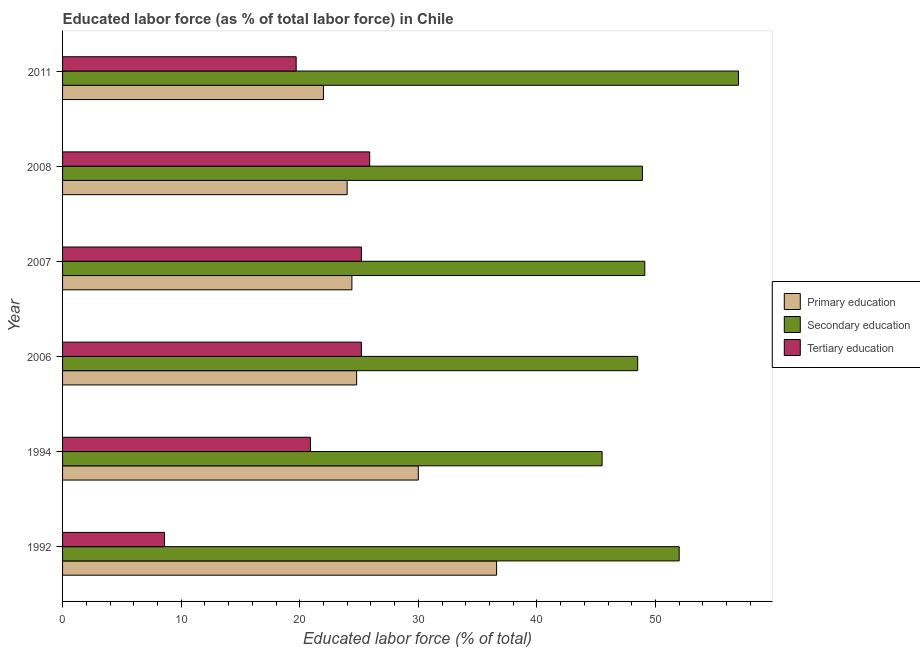Are the number of bars on each tick of the Y-axis equal?
Your answer should be compact. Yes. What is the label of the 2nd group of bars from the top?
Keep it short and to the point. 2008. What is the percentage of labor force who received primary education in 2007?
Your answer should be compact. 24.4. Across all years, what is the maximum percentage of labor force who received primary education?
Give a very brief answer. 36.6. Across all years, what is the minimum percentage of labor force who received tertiary education?
Ensure brevity in your answer.  8.6. What is the total percentage of labor force who received tertiary education in the graph?
Your response must be concise. 125.5. What is the difference between the percentage of labor force who received primary education in 2006 and the percentage of labor force who received tertiary education in 1994?
Offer a terse response. 3.9. What is the average percentage of labor force who received primary education per year?
Your response must be concise. 26.97. In the year 2006, what is the difference between the percentage of labor force who received secondary education and percentage of labor force who received primary education?
Give a very brief answer. 23.7. What is the ratio of the percentage of labor force who received secondary education in 2008 to that in 2011?
Provide a succinct answer. 0.86. Is the difference between the percentage of labor force who received secondary education in 2006 and 2008 greater than the difference between the percentage of labor force who received primary education in 2006 and 2008?
Provide a short and direct response. No. What is the difference between the highest and the lowest percentage of labor force who received secondary education?
Give a very brief answer. 11.5. In how many years, is the percentage of labor force who received secondary education greater than the average percentage of labor force who received secondary education taken over all years?
Provide a short and direct response. 2. Is the sum of the percentage of labor force who received primary education in 1994 and 2008 greater than the maximum percentage of labor force who received secondary education across all years?
Ensure brevity in your answer.  No. What does the 2nd bar from the bottom in 1994 represents?
Offer a terse response. Secondary education. How many bars are there?
Your answer should be very brief. 18. Are all the bars in the graph horizontal?
Your answer should be compact. Yes. How many years are there in the graph?
Offer a terse response. 6. What is the difference between two consecutive major ticks on the X-axis?
Provide a short and direct response. 10. Are the values on the major ticks of X-axis written in scientific E-notation?
Provide a succinct answer. No. How many legend labels are there?
Ensure brevity in your answer.  3. How are the legend labels stacked?
Keep it short and to the point. Vertical. What is the title of the graph?
Give a very brief answer. Educated labor force (as % of total labor force) in Chile. Does "Profit Tax" appear as one of the legend labels in the graph?
Make the answer very short. No. What is the label or title of the X-axis?
Your answer should be compact. Educated labor force (% of total). What is the Educated labor force (% of total) of Primary education in 1992?
Keep it short and to the point. 36.6. What is the Educated labor force (% of total) of Tertiary education in 1992?
Your answer should be compact. 8.6. What is the Educated labor force (% of total) of Primary education in 1994?
Ensure brevity in your answer.  30. What is the Educated labor force (% of total) of Secondary education in 1994?
Give a very brief answer. 45.5. What is the Educated labor force (% of total) in Tertiary education in 1994?
Ensure brevity in your answer.  20.9. What is the Educated labor force (% of total) of Primary education in 2006?
Provide a short and direct response. 24.8. What is the Educated labor force (% of total) in Secondary education in 2006?
Give a very brief answer. 48.5. What is the Educated labor force (% of total) in Tertiary education in 2006?
Give a very brief answer. 25.2. What is the Educated labor force (% of total) of Primary education in 2007?
Provide a short and direct response. 24.4. What is the Educated labor force (% of total) of Secondary education in 2007?
Keep it short and to the point. 49.1. What is the Educated labor force (% of total) in Tertiary education in 2007?
Give a very brief answer. 25.2. What is the Educated labor force (% of total) in Primary education in 2008?
Your answer should be compact. 24. What is the Educated labor force (% of total) in Secondary education in 2008?
Provide a succinct answer. 48.9. What is the Educated labor force (% of total) in Tertiary education in 2008?
Keep it short and to the point. 25.9. What is the Educated labor force (% of total) in Primary education in 2011?
Your answer should be compact. 22. What is the Educated labor force (% of total) of Tertiary education in 2011?
Your response must be concise. 19.7. Across all years, what is the maximum Educated labor force (% of total) of Primary education?
Your answer should be very brief. 36.6. Across all years, what is the maximum Educated labor force (% of total) in Secondary education?
Your answer should be very brief. 57. Across all years, what is the maximum Educated labor force (% of total) of Tertiary education?
Provide a succinct answer. 25.9. Across all years, what is the minimum Educated labor force (% of total) in Primary education?
Give a very brief answer. 22. Across all years, what is the minimum Educated labor force (% of total) of Secondary education?
Keep it short and to the point. 45.5. Across all years, what is the minimum Educated labor force (% of total) in Tertiary education?
Keep it short and to the point. 8.6. What is the total Educated labor force (% of total) of Primary education in the graph?
Your answer should be very brief. 161.8. What is the total Educated labor force (% of total) in Secondary education in the graph?
Provide a short and direct response. 301. What is the total Educated labor force (% of total) of Tertiary education in the graph?
Your answer should be compact. 125.5. What is the difference between the Educated labor force (% of total) of Primary education in 1992 and that in 1994?
Provide a short and direct response. 6.6. What is the difference between the Educated labor force (% of total) of Secondary education in 1992 and that in 1994?
Make the answer very short. 6.5. What is the difference between the Educated labor force (% of total) in Tertiary education in 1992 and that in 1994?
Your answer should be very brief. -12.3. What is the difference between the Educated labor force (% of total) of Secondary education in 1992 and that in 2006?
Provide a short and direct response. 3.5. What is the difference between the Educated labor force (% of total) in Tertiary education in 1992 and that in 2006?
Provide a succinct answer. -16.6. What is the difference between the Educated labor force (% of total) of Tertiary education in 1992 and that in 2007?
Provide a succinct answer. -16.6. What is the difference between the Educated labor force (% of total) of Tertiary education in 1992 and that in 2008?
Offer a terse response. -17.3. What is the difference between the Educated labor force (% of total) in Secondary education in 1992 and that in 2011?
Your answer should be very brief. -5. What is the difference between the Educated labor force (% of total) of Primary education in 1994 and that in 2007?
Your answer should be very brief. 5.6. What is the difference between the Educated labor force (% of total) of Secondary education in 1994 and that in 2007?
Offer a terse response. -3.6. What is the difference between the Educated labor force (% of total) of Tertiary education in 1994 and that in 2007?
Provide a short and direct response. -4.3. What is the difference between the Educated labor force (% of total) of Primary education in 1994 and that in 2008?
Keep it short and to the point. 6. What is the difference between the Educated labor force (% of total) in Secondary education in 1994 and that in 2008?
Your answer should be very brief. -3.4. What is the difference between the Educated labor force (% of total) of Tertiary education in 1994 and that in 2008?
Keep it short and to the point. -5. What is the difference between the Educated labor force (% of total) in Primary education in 1994 and that in 2011?
Provide a short and direct response. 8. What is the difference between the Educated labor force (% of total) in Secondary education in 1994 and that in 2011?
Ensure brevity in your answer.  -11.5. What is the difference between the Educated labor force (% of total) of Primary education in 2006 and that in 2007?
Provide a succinct answer. 0.4. What is the difference between the Educated labor force (% of total) in Secondary education in 2006 and that in 2007?
Keep it short and to the point. -0.6. What is the difference between the Educated labor force (% of total) in Tertiary education in 2006 and that in 2007?
Make the answer very short. 0. What is the difference between the Educated labor force (% of total) in Primary education in 2006 and that in 2008?
Ensure brevity in your answer.  0.8. What is the difference between the Educated labor force (% of total) of Secondary education in 2006 and that in 2008?
Keep it short and to the point. -0.4. What is the difference between the Educated labor force (% of total) in Secondary education in 2006 and that in 2011?
Give a very brief answer. -8.5. What is the difference between the Educated labor force (% of total) in Primary education in 2007 and that in 2008?
Ensure brevity in your answer.  0.4. What is the difference between the Educated labor force (% of total) in Secondary education in 2007 and that in 2008?
Offer a terse response. 0.2. What is the difference between the Educated labor force (% of total) of Tertiary education in 2007 and that in 2008?
Offer a terse response. -0.7. What is the difference between the Educated labor force (% of total) in Secondary education in 2007 and that in 2011?
Keep it short and to the point. -7.9. What is the difference between the Educated labor force (% of total) of Primary education in 2008 and that in 2011?
Your response must be concise. 2. What is the difference between the Educated labor force (% of total) of Secondary education in 2008 and that in 2011?
Ensure brevity in your answer.  -8.1. What is the difference between the Educated labor force (% of total) of Primary education in 1992 and the Educated labor force (% of total) of Secondary education in 1994?
Give a very brief answer. -8.9. What is the difference between the Educated labor force (% of total) of Primary education in 1992 and the Educated labor force (% of total) of Tertiary education in 1994?
Provide a succinct answer. 15.7. What is the difference between the Educated labor force (% of total) in Secondary education in 1992 and the Educated labor force (% of total) in Tertiary education in 1994?
Your answer should be compact. 31.1. What is the difference between the Educated labor force (% of total) in Primary education in 1992 and the Educated labor force (% of total) in Secondary education in 2006?
Your response must be concise. -11.9. What is the difference between the Educated labor force (% of total) of Primary education in 1992 and the Educated labor force (% of total) of Tertiary education in 2006?
Ensure brevity in your answer.  11.4. What is the difference between the Educated labor force (% of total) of Secondary education in 1992 and the Educated labor force (% of total) of Tertiary education in 2006?
Your answer should be compact. 26.8. What is the difference between the Educated labor force (% of total) in Secondary education in 1992 and the Educated labor force (% of total) in Tertiary education in 2007?
Keep it short and to the point. 26.8. What is the difference between the Educated labor force (% of total) in Primary education in 1992 and the Educated labor force (% of total) in Secondary education in 2008?
Make the answer very short. -12.3. What is the difference between the Educated labor force (% of total) in Secondary education in 1992 and the Educated labor force (% of total) in Tertiary education in 2008?
Keep it short and to the point. 26.1. What is the difference between the Educated labor force (% of total) of Primary education in 1992 and the Educated labor force (% of total) of Secondary education in 2011?
Make the answer very short. -20.4. What is the difference between the Educated labor force (% of total) of Primary education in 1992 and the Educated labor force (% of total) of Tertiary education in 2011?
Your answer should be compact. 16.9. What is the difference between the Educated labor force (% of total) in Secondary education in 1992 and the Educated labor force (% of total) in Tertiary education in 2011?
Ensure brevity in your answer.  32.3. What is the difference between the Educated labor force (% of total) of Primary education in 1994 and the Educated labor force (% of total) of Secondary education in 2006?
Offer a terse response. -18.5. What is the difference between the Educated labor force (% of total) of Primary education in 1994 and the Educated labor force (% of total) of Tertiary education in 2006?
Your answer should be compact. 4.8. What is the difference between the Educated labor force (% of total) in Secondary education in 1994 and the Educated labor force (% of total) in Tertiary education in 2006?
Give a very brief answer. 20.3. What is the difference between the Educated labor force (% of total) in Primary education in 1994 and the Educated labor force (% of total) in Secondary education in 2007?
Your response must be concise. -19.1. What is the difference between the Educated labor force (% of total) of Primary education in 1994 and the Educated labor force (% of total) of Tertiary education in 2007?
Your answer should be compact. 4.8. What is the difference between the Educated labor force (% of total) in Secondary education in 1994 and the Educated labor force (% of total) in Tertiary education in 2007?
Ensure brevity in your answer.  20.3. What is the difference between the Educated labor force (% of total) of Primary education in 1994 and the Educated labor force (% of total) of Secondary education in 2008?
Ensure brevity in your answer.  -18.9. What is the difference between the Educated labor force (% of total) in Secondary education in 1994 and the Educated labor force (% of total) in Tertiary education in 2008?
Offer a very short reply. 19.6. What is the difference between the Educated labor force (% of total) of Secondary education in 1994 and the Educated labor force (% of total) of Tertiary education in 2011?
Give a very brief answer. 25.8. What is the difference between the Educated labor force (% of total) in Primary education in 2006 and the Educated labor force (% of total) in Secondary education in 2007?
Provide a short and direct response. -24.3. What is the difference between the Educated labor force (% of total) in Primary education in 2006 and the Educated labor force (% of total) in Tertiary education in 2007?
Offer a terse response. -0.4. What is the difference between the Educated labor force (% of total) of Secondary education in 2006 and the Educated labor force (% of total) of Tertiary education in 2007?
Give a very brief answer. 23.3. What is the difference between the Educated labor force (% of total) in Primary education in 2006 and the Educated labor force (% of total) in Secondary education in 2008?
Your response must be concise. -24.1. What is the difference between the Educated labor force (% of total) of Primary education in 2006 and the Educated labor force (% of total) of Tertiary education in 2008?
Provide a short and direct response. -1.1. What is the difference between the Educated labor force (% of total) of Secondary education in 2006 and the Educated labor force (% of total) of Tertiary education in 2008?
Offer a terse response. 22.6. What is the difference between the Educated labor force (% of total) in Primary education in 2006 and the Educated labor force (% of total) in Secondary education in 2011?
Your answer should be very brief. -32.2. What is the difference between the Educated labor force (% of total) in Primary education in 2006 and the Educated labor force (% of total) in Tertiary education in 2011?
Offer a very short reply. 5.1. What is the difference between the Educated labor force (% of total) of Secondary education in 2006 and the Educated labor force (% of total) of Tertiary education in 2011?
Keep it short and to the point. 28.8. What is the difference between the Educated labor force (% of total) of Primary education in 2007 and the Educated labor force (% of total) of Secondary education in 2008?
Keep it short and to the point. -24.5. What is the difference between the Educated labor force (% of total) in Primary education in 2007 and the Educated labor force (% of total) in Tertiary education in 2008?
Keep it short and to the point. -1.5. What is the difference between the Educated labor force (% of total) in Secondary education in 2007 and the Educated labor force (% of total) in Tertiary education in 2008?
Your answer should be compact. 23.2. What is the difference between the Educated labor force (% of total) of Primary education in 2007 and the Educated labor force (% of total) of Secondary education in 2011?
Give a very brief answer. -32.6. What is the difference between the Educated labor force (% of total) in Primary education in 2007 and the Educated labor force (% of total) in Tertiary education in 2011?
Offer a terse response. 4.7. What is the difference between the Educated labor force (% of total) of Secondary education in 2007 and the Educated labor force (% of total) of Tertiary education in 2011?
Your response must be concise. 29.4. What is the difference between the Educated labor force (% of total) of Primary education in 2008 and the Educated labor force (% of total) of Secondary education in 2011?
Your answer should be compact. -33. What is the difference between the Educated labor force (% of total) in Secondary education in 2008 and the Educated labor force (% of total) in Tertiary education in 2011?
Provide a succinct answer. 29.2. What is the average Educated labor force (% of total) of Primary education per year?
Give a very brief answer. 26.97. What is the average Educated labor force (% of total) of Secondary education per year?
Keep it short and to the point. 50.17. What is the average Educated labor force (% of total) in Tertiary education per year?
Offer a terse response. 20.92. In the year 1992, what is the difference between the Educated labor force (% of total) in Primary education and Educated labor force (% of total) in Secondary education?
Keep it short and to the point. -15.4. In the year 1992, what is the difference between the Educated labor force (% of total) in Primary education and Educated labor force (% of total) in Tertiary education?
Provide a short and direct response. 28. In the year 1992, what is the difference between the Educated labor force (% of total) in Secondary education and Educated labor force (% of total) in Tertiary education?
Your response must be concise. 43.4. In the year 1994, what is the difference between the Educated labor force (% of total) in Primary education and Educated labor force (% of total) in Secondary education?
Give a very brief answer. -15.5. In the year 1994, what is the difference between the Educated labor force (% of total) in Primary education and Educated labor force (% of total) in Tertiary education?
Keep it short and to the point. 9.1. In the year 1994, what is the difference between the Educated labor force (% of total) of Secondary education and Educated labor force (% of total) of Tertiary education?
Keep it short and to the point. 24.6. In the year 2006, what is the difference between the Educated labor force (% of total) in Primary education and Educated labor force (% of total) in Secondary education?
Give a very brief answer. -23.7. In the year 2006, what is the difference between the Educated labor force (% of total) of Secondary education and Educated labor force (% of total) of Tertiary education?
Make the answer very short. 23.3. In the year 2007, what is the difference between the Educated labor force (% of total) of Primary education and Educated labor force (% of total) of Secondary education?
Your response must be concise. -24.7. In the year 2007, what is the difference between the Educated labor force (% of total) in Primary education and Educated labor force (% of total) in Tertiary education?
Your answer should be very brief. -0.8. In the year 2007, what is the difference between the Educated labor force (% of total) of Secondary education and Educated labor force (% of total) of Tertiary education?
Ensure brevity in your answer.  23.9. In the year 2008, what is the difference between the Educated labor force (% of total) of Primary education and Educated labor force (% of total) of Secondary education?
Your answer should be compact. -24.9. In the year 2008, what is the difference between the Educated labor force (% of total) in Secondary education and Educated labor force (% of total) in Tertiary education?
Provide a succinct answer. 23. In the year 2011, what is the difference between the Educated labor force (% of total) in Primary education and Educated labor force (% of total) in Secondary education?
Offer a very short reply. -35. In the year 2011, what is the difference between the Educated labor force (% of total) of Secondary education and Educated labor force (% of total) of Tertiary education?
Keep it short and to the point. 37.3. What is the ratio of the Educated labor force (% of total) in Primary education in 1992 to that in 1994?
Offer a terse response. 1.22. What is the ratio of the Educated labor force (% of total) in Tertiary education in 1992 to that in 1994?
Your response must be concise. 0.41. What is the ratio of the Educated labor force (% of total) in Primary education in 1992 to that in 2006?
Offer a terse response. 1.48. What is the ratio of the Educated labor force (% of total) of Secondary education in 1992 to that in 2006?
Your answer should be compact. 1.07. What is the ratio of the Educated labor force (% of total) in Tertiary education in 1992 to that in 2006?
Your answer should be compact. 0.34. What is the ratio of the Educated labor force (% of total) in Secondary education in 1992 to that in 2007?
Make the answer very short. 1.06. What is the ratio of the Educated labor force (% of total) of Tertiary education in 1992 to that in 2007?
Your response must be concise. 0.34. What is the ratio of the Educated labor force (% of total) in Primary education in 1992 to that in 2008?
Offer a very short reply. 1.52. What is the ratio of the Educated labor force (% of total) of Secondary education in 1992 to that in 2008?
Your response must be concise. 1.06. What is the ratio of the Educated labor force (% of total) of Tertiary education in 1992 to that in 2008?
Give a very brief answer. 0.33. What is the ratio of the Educated labor force (% of total) in Primary education in 1992 to that in 2011?
Offer a terse response. 1.66. What is the ratio of the Educated labor force (% of total) of Secondary education in 1992 to that in 2011?
Ensure brevity in your answer.  0.91. What is the ratio of the Educated labor force (% of total) in Tertiary education in 1992 to that in 2011?
Keep it short and to the point. 0.44. What is the ratio of the Educated labor force (% of total) in Primary education in 1994 to that in 2006?
Keep it short and to the point. 1.21. What is the ratio of the Educated labor force (% of total) of Secondary education in 1994 to that in 2006?
Offer a very short reply. 0.94. What is the ratio of the Educated labor force (% of total) in Tertiary education in 1994 to that in 2006?
Your answer should be very brief. 0.83. What is the ratio of the Educated labor force (% of total) of Primary education in 1994 to that in 2007?
Make the answer very short. 1.23. What is the ratio of the Educated labor force (% of total) of Secondary education in 1994 to that in 2007?
Your answer should be compact. 0.93. What is the ratio of the Educated labor force (% of total) of Tertiary education in 1994 to that in 2007?
Your answer should be very brief. 0.83. What is the ratio of the Educated labor force (% of total) of Primary education in 1994 to that in 2008?
Offer a very short reply. 1.25. What is the ratio of the Educated labor force (% of total) of Secondary education in 1994 to that in 2008?
Your answer should be very brief. 0.93. What is the ratio of the Educated labor force (% of total) in Tertiary education in 1994 to that in 2008?
Your response must be concise. 0.81. What is the ratio of the Educated labor force (% of total) of Primary education in 1994 to that in 2011?
Keep it short and to the point. 1.36. What is the ratio of the Educated labor force (% of total) in Secondary education in 1994 to that in 2011?
Offer a very short reply. 0.8. What is the ratio of the Educated labor force (% of total) in Tertiary education in 1994 to that in 2011?
Provide a succinct answer. 1.06. What is the ratio of the Educated labor force (% of total) in Primary education in 2006 to that in 2007?
Your response must be concise. 1.02. What is the ratio of the Educated labor force (% of total) in Secondary education in 2006 to that in 2008?
Offer a terse response. 0.99. What is the ratio of the Educated labor force (% of total) of Primary education in 2006 to that in 2011?
Provide a short and direct response. 1.13. What is the ratio of the Educated labor force (% of total) of Secondary education in 2006 to that in 2011?
Your response must be concise. 0.85. What is the ratio of the Educated labor force (% of total) in Tertiary education in 2006 to that in 2011?
Your answer should be compact. 1.28. What is the ratio of the Educated labor force (% of total) in Primary education in 2007 to that in 2008?
Make the answer very short. 1.02. What is the ratio of the Educated labor force (% of total) in Secondary education in 2007 to that in 2008?
Your answer should be compact. 1. What is the ratio of the Educated labor force (% of total) of Primary education in 2007 to that in 2011?
Your response must be concise. 1.11. What is the ratio of the Educated labor force (% of total) in Secondary education in 2007 to that in 2011?
Offer a very short reply. 0.86. What is the ratio of the Educated labor force (% of total) of Tertiary education in 2007 to that in 2011?
Your answer should be very brief. 1.28. What is the ratio of the Educated labor force (% of total) of Primary education in 2008 to that in 2011?
Give a very brief answer. 1.09. What is the ratio of the Educated labor force (% of total) of Secondary education in 2008 to that in 2011?
Give a very brief answer. 0.86. What is the ratio of the Educated labor force (% of total) of Tertiary education in 2008 to that in 2011?
Keep it short and to the point. 1.31. What is the difference between the highest and the second highest Educated labor force (% of total) of Secondary education?
Provide a short and direct response. 5. What is the difference between the highest and the second highest Educated labor force (% of total) of Tertiary education?
Give a very brief answer. 0.7. What is the difference between the highest and the lowest Educated labor force (% of total) in Primary education?
Give a very brief answer. 14.6. 